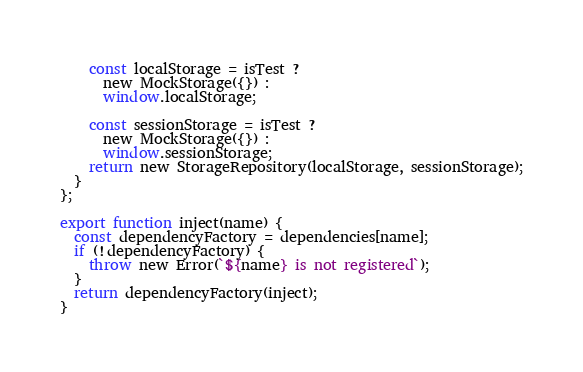<code> <loc_0><loc_0><loc_500><loc_500><_JavaScript_>    const localStorage = isTest ?
      new MockStorage({}) :
      window.localStorage;

    const sessionStorage = isTest ?
      new MockStorage({}) :
      window.sessionStorage;
    return new StorageRepository(localStorage, sessionStorage);
  }
};

export function inject(name) {
  const dependencyFactory = dependencies[name];
  if (!dependencyFactory) {
    throw new Error(`${name} is not registered`);
  }
  return dependencyFactory(inject);
}</code> 